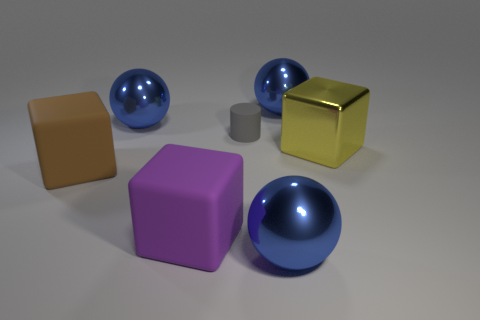The cylinder that is the same material as the purple object is what size?
Your answer should be very brief. Small. What number of large brown rubber things are the same shape as the large yellow metal object?
Ensure brevity in your answer.  1. Is there any other thing that is the same size as the yellow metallic cube?
Make the answer very short. Yes. What is the size of the matte object that is behind the yellow metallic object behind the large brown block?
Offer a terse response. Small. There is a purple thing that is the same size as the brown matte cube; what material is it?
Provide a succinct answer. Rubber. Is there a small cyan cylinder that has the same material as the big brown object?
Provide a short and direct response. No. What is the color of the cube that is to the right of the big blue shiny object behind the blue sphere left of the purple rubber cube?
Your answer should be very brief. Yellow. Does the large shiny ball that is to the left of the tiny matte cylinder have the same color as the ball in front of the yellow metallic thing?
Your answer should be very brief. Yes. Is there any other thing that is the same color as the tiny matte thing?
Give a very brief answer. No. Is the number of blue metal things right of the large purple cube less than the number of blue shiny objects?
Offer a terse response. Yes. 